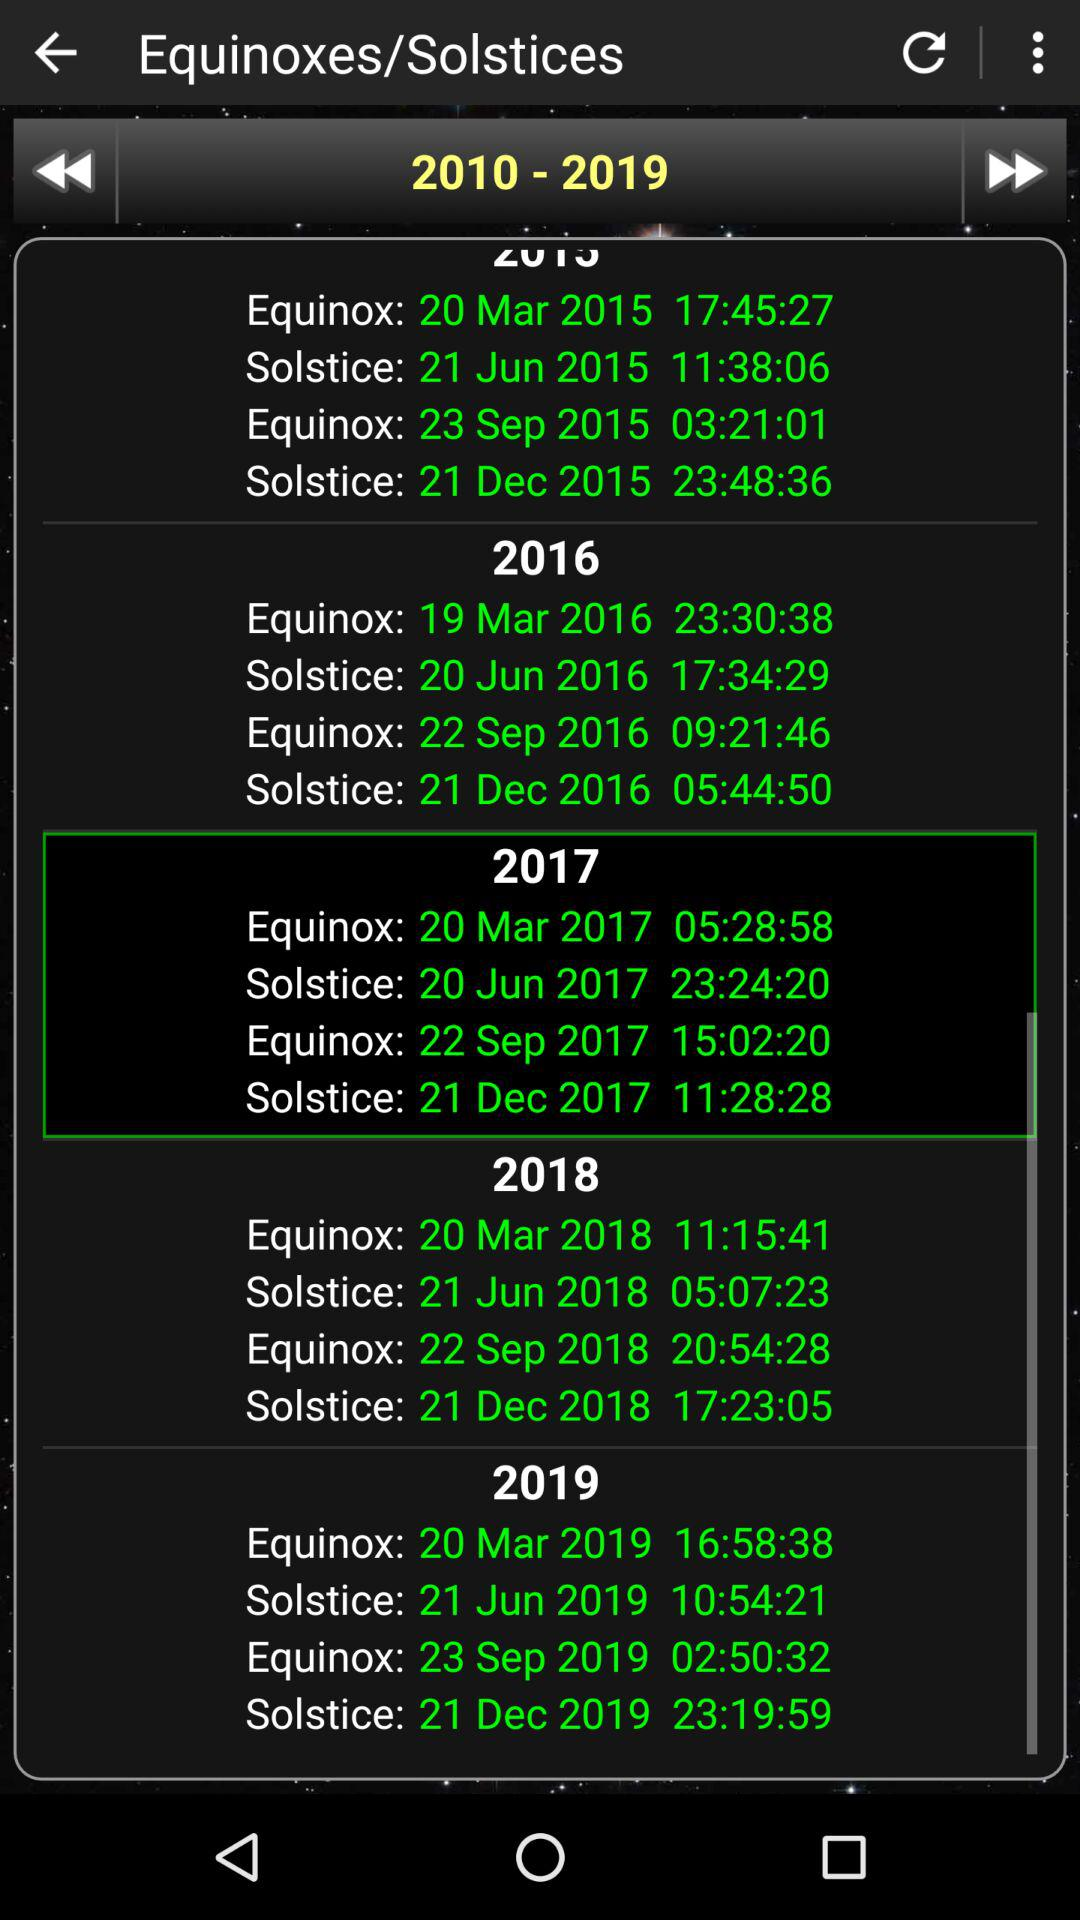What is the given range of years? The given range of years is from 2010 to 2019. 